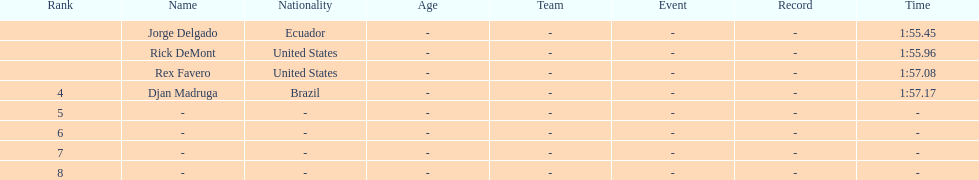What come after rex f. Djan Madruga. 